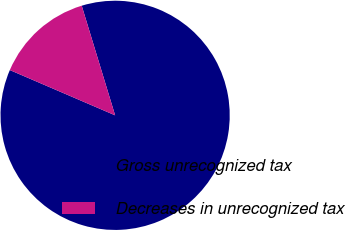Convert chart to OTSL. <chart><loc_0><loc_0><loc_500><loc_500><pie_chart><fcel>Gross unrecognized tax<fcel>Decreases in unrecognized tax<nl><fcel>86.17%<fcel>13.83%<nl></chart> 